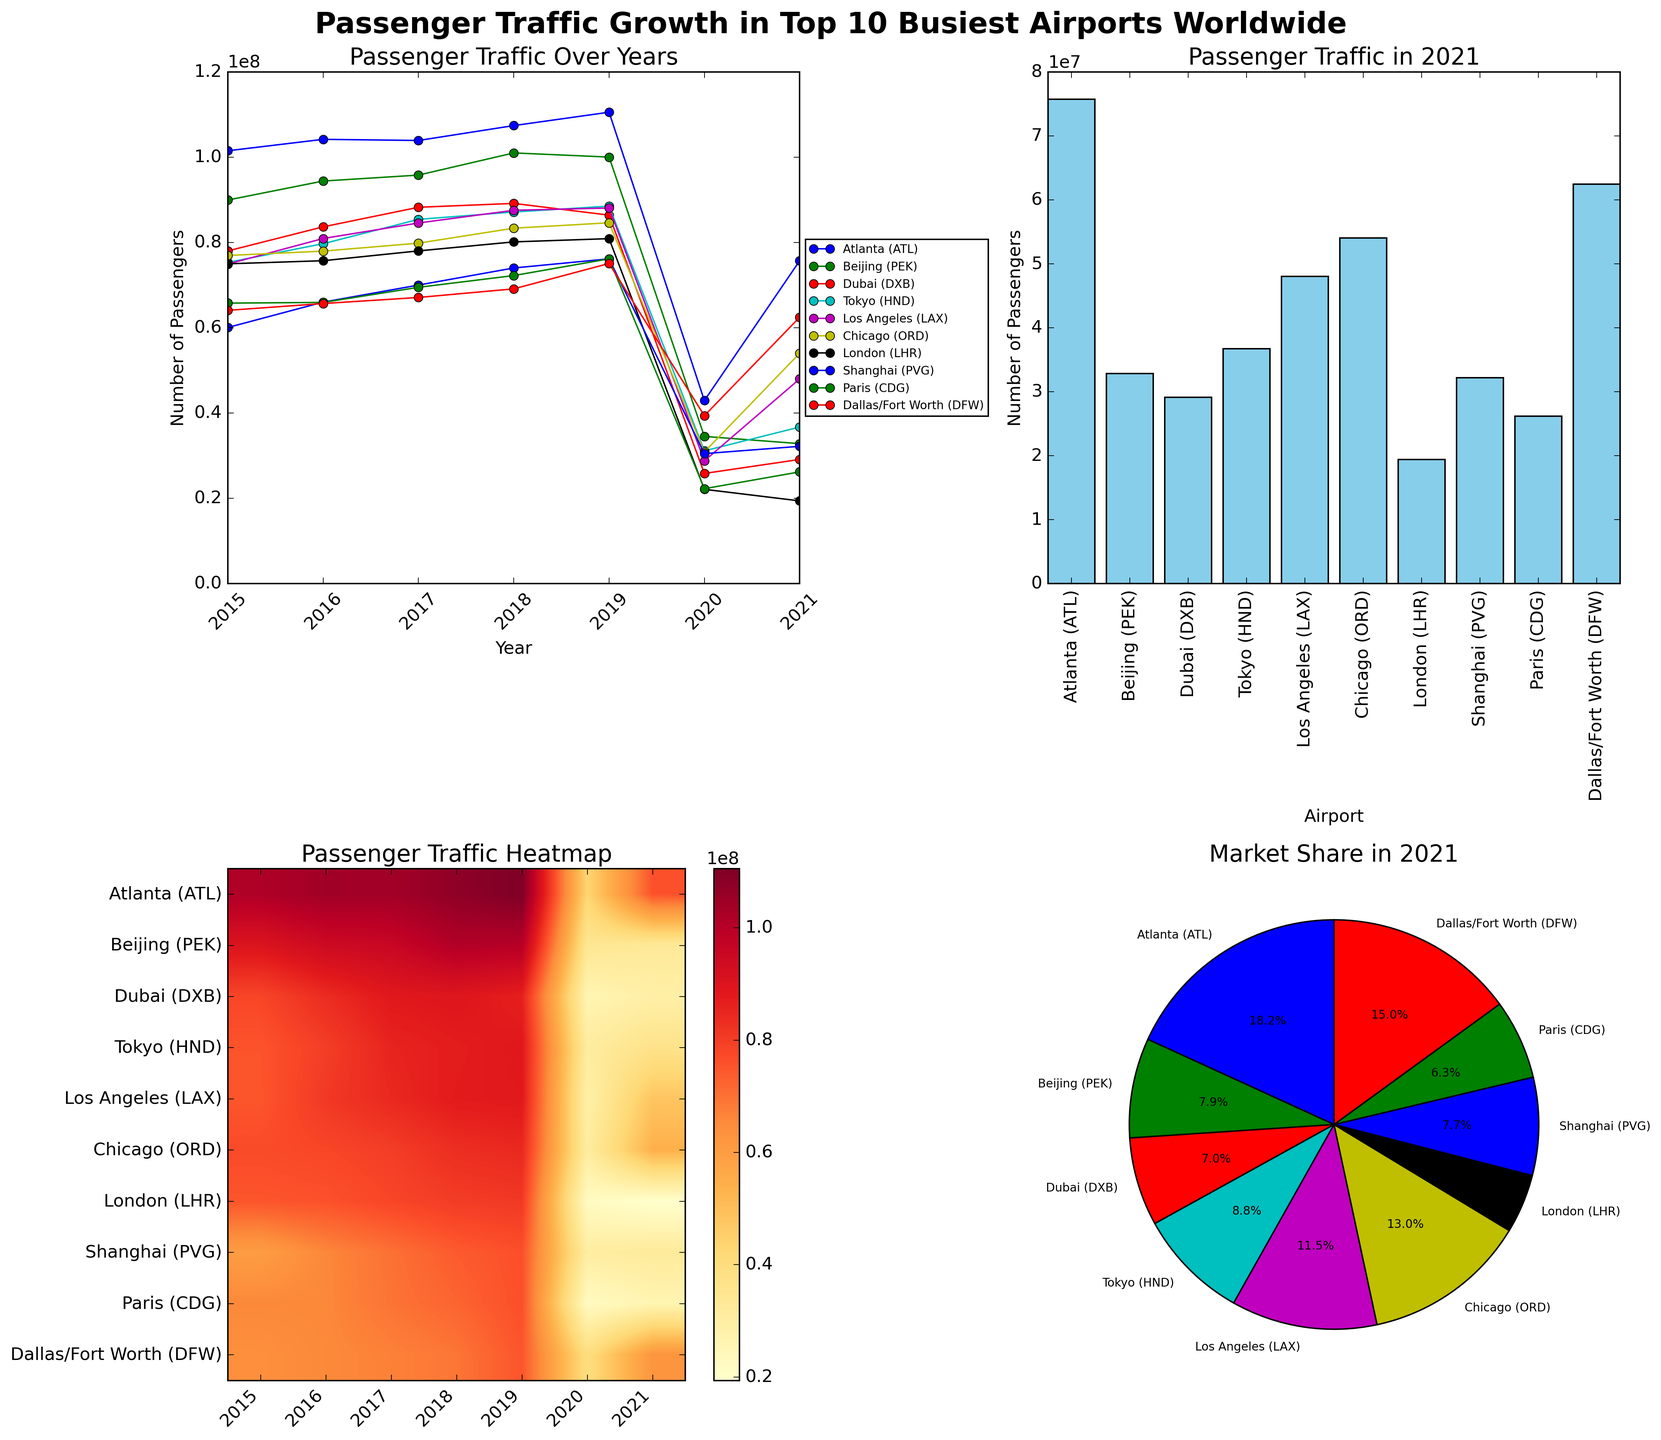What is the highest passenger traffic recorded among the top 10 busiest airports worldwide in 2019? In the line plot, check the value for each airport in 2019. The highest value is shown for Atlanta (ATL) with 110,531,300 passengers.
Answer: 110,531,300 Which airport had the least passenger traffic in 2021? Refer to the bar plot for the passenger traffic in 2021. The shortest bar represents London (LHR) with 19,394,810 passengers.
Answer: London (LHR) How did the passenger traffic in 2021 compare to 2020 for Dallas/Fort Worth (DFW)? In the line plot, compare the values marked for DFW in 2020 (39,364,990) and 2021 (62,465,756). DFW's passenger traffic increases from 2020 to 2021.
Answer: Increased What is the total passenger traffic in 2021 for all the airports combined? Sum the values for all airports in the bar plot for 2021. The total is 75,704,760 + 32,816,520 + 29,110,609 + 36,708,119 + 48,007,284 + 54,020,399 + 19,394,810 + 32,191,402 + 26,196,802 + 62,465,756 = 416,616,461.
Answer: 416,616,461 Which year shows the most notable drop in passenger traffic overall? Observe the line plot's overall trends. A significant drop is noticeable in 2020, indicating the impact of the COVID-19 pandemic.
Answer: 2020 Compare the passenger traffic of Beijing (PEK) and Tokyo (HND) in 2017. Which airport had higher traffic? In the line plot, find the values for PEK and HND in 2017. PEK had 95,786,442 passengers, whereas HND had 85,408,975 passengers. PEK had higher traffic.
Answer: Beijing (PEK) What percentage of market share in 2021 did Los Angeles (LAX) hold among these airports? Refer to the pie chart. Each segment's percentage is visible. LAX holds the segment labeled 11.5%.
Answer: 11.5% Did passenger traffic at Paris (CDG) increase or decrease from 2015 to 2021? Check the trend line for CDG from 2015 (65,766,986 passengers) to 2021 (26,196,802 passengers) in the line plot. The traffic decreased over these years.
Answer: Decreased What is the average number of passengers in 2021 across all airports? Compute the total passenger traffic in 2021 (416,616,461) and divide by the number of airports (10). Average = 416,616,461 / 10 = 41,661,646.1
Answer: 41,661,646.1 